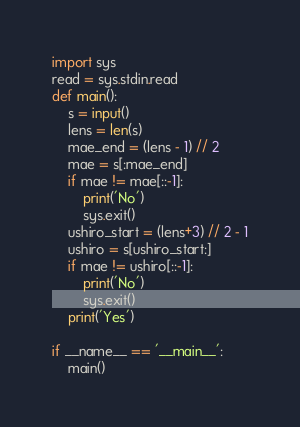<code> <loc_0><loc_0><loc_500><loc_500><_Python_>import sys
read = sys.stdin.read
def main():
    s = input()
    lens = len(s)
    mae_end = (lens - 1) // 2
    mae = s[:mae_end]
    if mae != mae[::-1]:
        print('No')
        sys.exit()
    ushiro_start = (lens+3) // 2 - 1
    ushiro = s[ushiro_start:]
    if mae != ushiro[::-1]:
        print('No')
        sys.exit()
    print('Yes')

if __name__ == '__main__':
    main()
</code> 